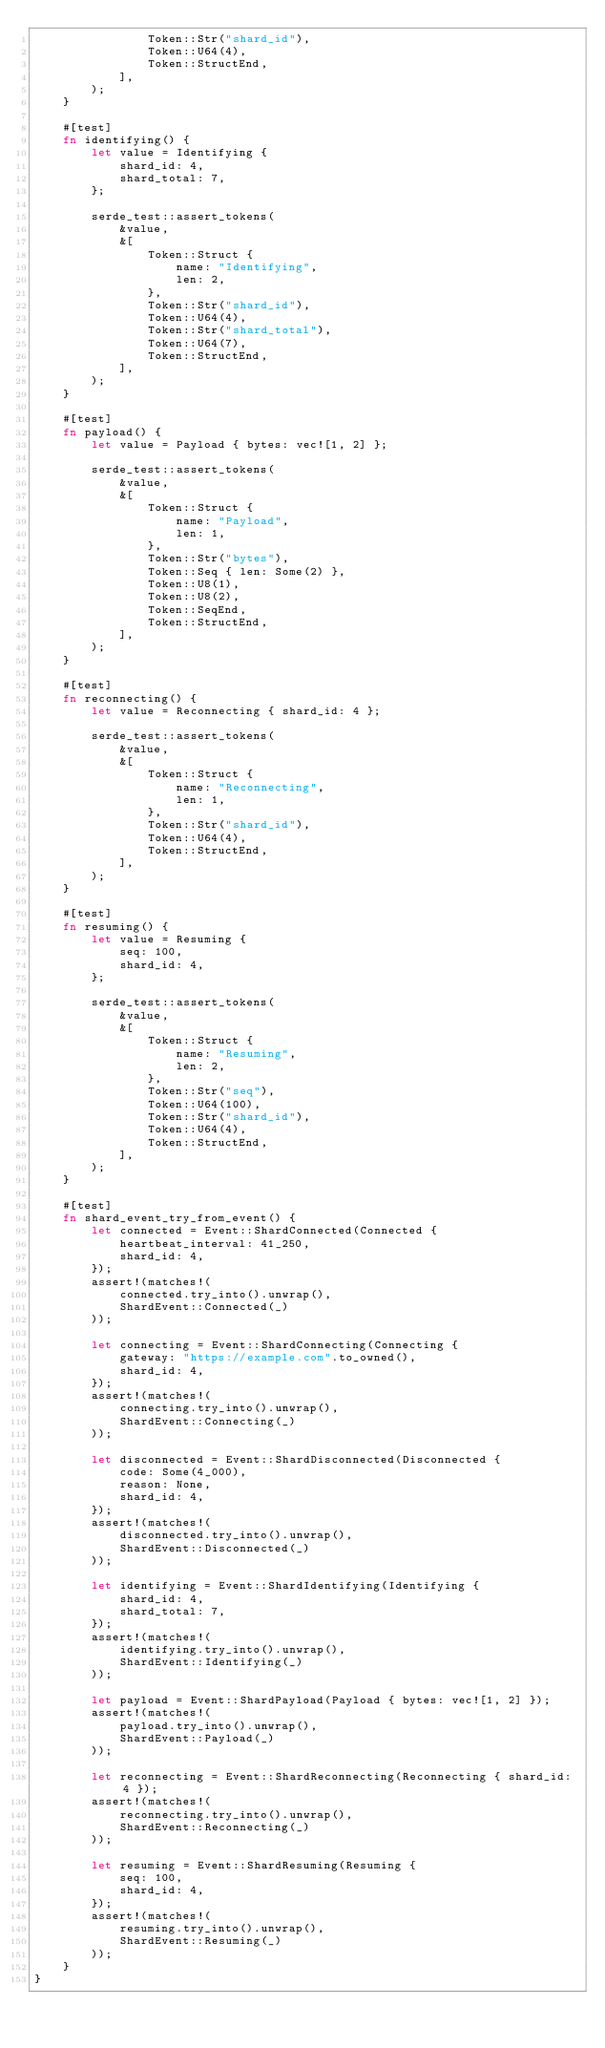<code> <loc_0><loc_0><loc_500><loc_500><_Rust_>                Token::Str("shard_id"),
                Token::U64(4),
                Token::StructEnd,
            ],
        );
    }

    #[test]
    fn identifying() {
        let value = Identifying {
            shard_id: 4,
            shard_total: 7,
        };

        serde_test::assert_tokens(
            &value,
            &[
                Token::Struct {
                    name: "Identifying",
                    len: 2,
                },
                Token::Str("shard_id"),
                Token::U64(4),
                Token::Str("shard_total"),
                Token::U64(7),
                Token::StructEnd,
            ],
        );
    }

    #[test]
    fn payload() {
        let value = Payload { bytes: vec![1, 2] };

        serde_test::assert_tokens(
            &value,
            &[
                Token::Struct {
                    name: "Payload",
                    len: 1,
                },
                Token::Str("bytes"),
                Token::Seq { len: Some(2) },
                Token::U8(1),
                Token::U8(2),
                Token::SeqEnd,
                Token::StructEnd,
            ],
        );
    }

    #[test]
    fn reconnecting() {
        let value = Reconnecting { shard_id: 4 };

        serde_test::assert_tokens(
            &value,
            &[
                Token::Struct {
                    name: "Reconnecting",
                    len: 1,
                },
                Token::Str("shard_id"),
                Token::U64(4),
                Token::StructEnd,
            ],
        );
    }

    #[test]
    fn resuming() {
        let value = Resuming {
            seq: 100,
            shard_id: 4,
        };

        serde_test::assert_tokens(
            &value,
            &[
                Token::Struct {
                    name: "Resuming",
                    len: 2,
                },
                Token::Str("seq"),
                Token::U64(100),
                Token::Str("shard_id"),
                Token::U64(4),
                Token::StructEnd,
            ],
        );
    }

    #[test]
    fn shard_event_try_from_event() {
        let connected = Event::ShardConnected(Connected {
            heartbeat_interval: 41_250,
            shard_id: 4,
        });
        assert!(matches!(
            connected.try_into().unwrap(),
            ShardEvent::Connected(_)
        ));

        let connecting = Event::ShardConnecting(Connecting {
            gateway: "https://example.com".to_owned(),
            shard_id: 4,
        });
        assert!(matches!(
            connecting.try_into().unwrap(),
            ShardEvent::Connecting(_)
        ));

        let disconnected = Event::ShardDisconnected(Disconnected {
            code: Some(4_000),
            reason: None,
            shard_id: 4,
        });
        assert!(matches!(
            disconnected.try_into().unwrap(),
            ShardEvent::Disconnected(_)
        ));

        let identifying = Event::ShardIdentifying(Identifying {
            shard_id: 4,
            shard_total: 7,
        });
        assert!(matches!(
            identifying.try_into().unwrap(),
            ShardEvent::Identifying(_)
        ));

        let payload = Event::ShardPayload(Payload { bytes: vec![1, 2] });
        assert!(matches!(
            payload.try_into().unwrap(),
            ShardEvent::Payload(_)
        ));

        let reconnecting = Event::ShardReconnecting(Reconnecting { shard_id: 4 });
        assert!(matches!(
            reconnecting.try_into().unwrap(),
            ShardEvent::Reconnecting(_)
        ));

        let resuming = Event::ShardResuming(Resuming {
            seq: 100,
            shard_id: 4,
        });
        assert!(matches!(
            resuming.try_into().unwrap(),
            ShardEvent::Resuming(_)
        ));
    }
}
</code> 